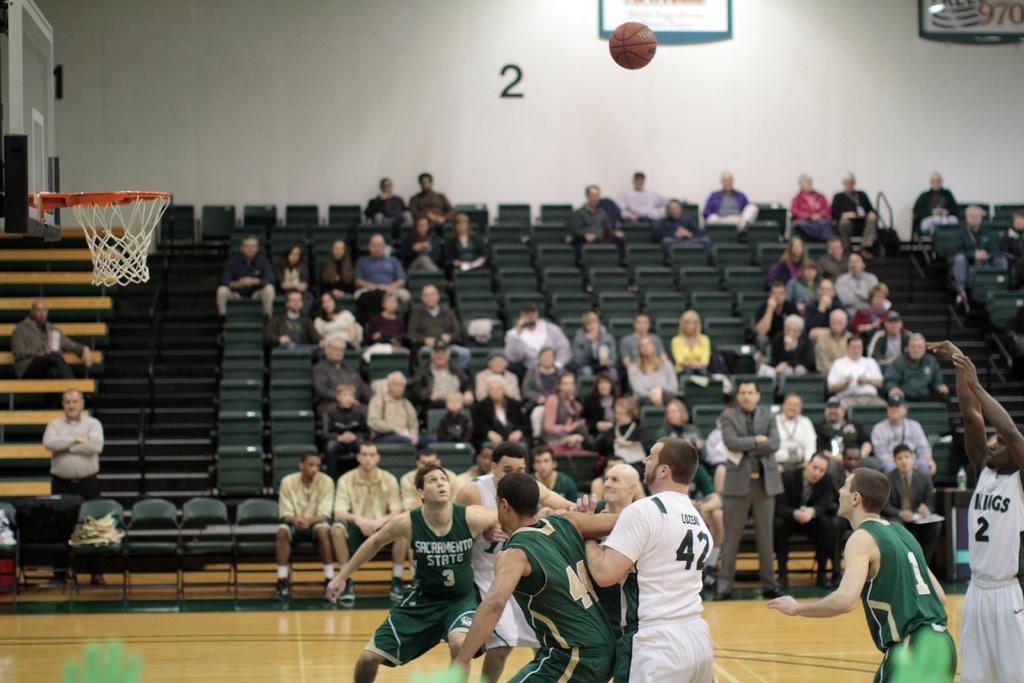Whats the number on the wall?
Offer a very short reply. 2. 